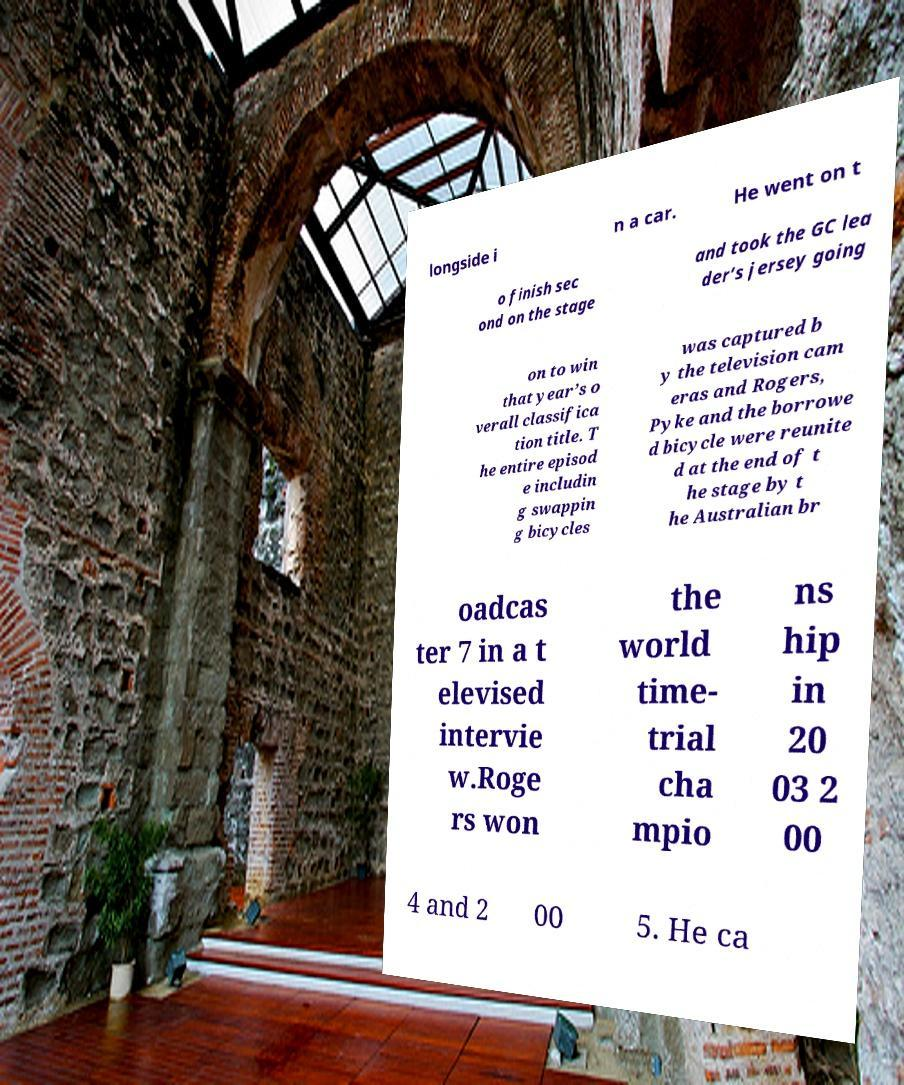Could you assist in decoding the text presented in this image and type it out clearly? longside i n a car. He went on t o finish sec ond on the stage and took the GC lea der’s jersey going on to win that year’s o verall classifica tion title. T he entire episod e includin g swappin g bicycles was captured b y the television cam eras and Rogers, Pyke and the borrowe d bicycle were reunite d at the end of t he stage by t he Australian br oadcas ter 7 in a t elevised intervie w.Roge rs won the world time- trial cha mpio ns hip in 20 03 2 00 4 and 2 00 5. He ca 